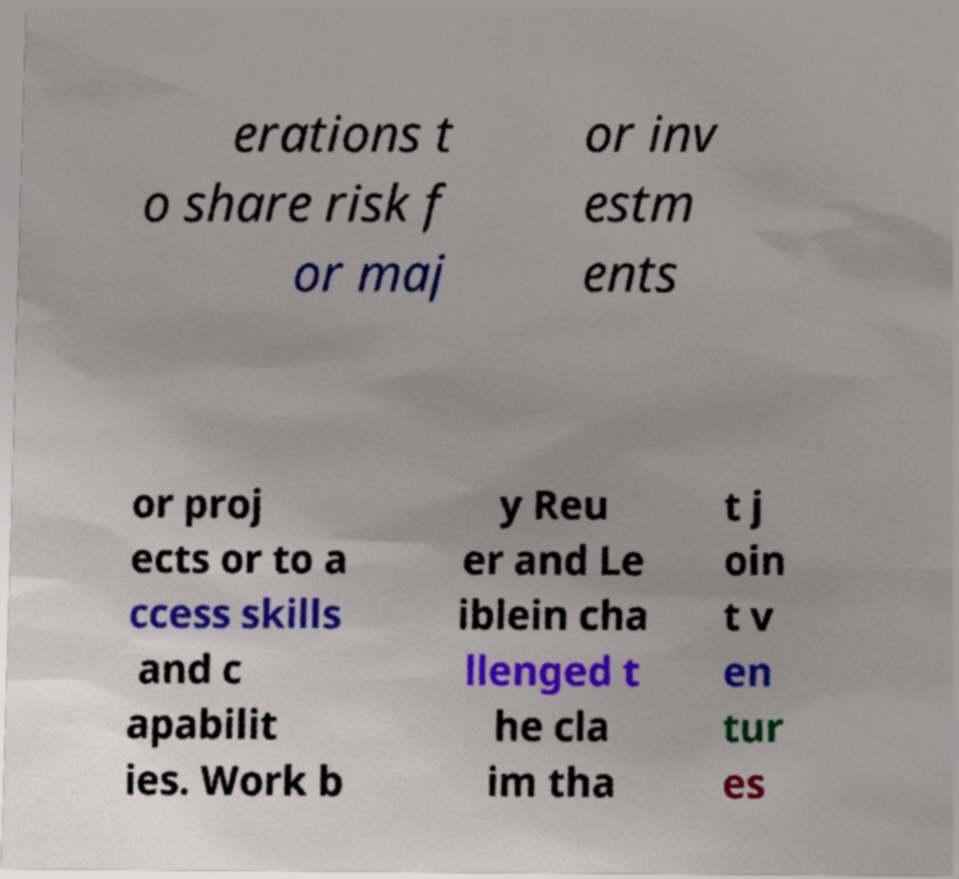For documentation purposes, I need the text within this image transcribed. Could you provide that? erations t o share risk f or maj or inv estm ents or proj ects or to a ccess skills and c apabilit ies. Work b y Reu er and Le iblein cha llenged t he cla im tha t j oin t v en tur es 